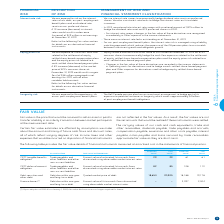According to Bce's financial document, What is fair value? the price that would be received to sell an asset or paid to transfer a liability in an orderly transaction between market participants at the measurement date.. The document states: "Fair value is the price that would be received to sell an asset or paid to transfer a liability in an orderly transaction between market participants ..." Also, What is the fair value methodology for debt securities and other debt? Quoted market price of debt. The document states: "debt Debt due within one year and long-term debt Quoted market price of debt 18,653 20,905 18,188 19,178..." Also, Which segments approximate fair value as they are short-term? The carrying values of our cash and cash equivalents, trade and other receivables, dividends payable, trade payables and accruals, compensation payable, severance and other costs payable, interest payable, notes payable and loans secured by trade receivables. The document states: "The carrying values of our cash and cash equivalents, trade and other receivables, dividends payable, trade payables and accruals, compensation payabl..." Also, can you calculate: What is the percentage change in carrying values for CRTC deferral account obligation in 2019? To answer this question, I need to perform calculations using the financial data. The calculation is: (82-108)/108, which equals -24.07 (percentage). This is based on the information: "nted using observable market interest rates 82 85 108 112 discounted using observable market interest rates 82 85 108 112..." The key data points involved are: 108, 82. Also, can you calculate: What is the percentage change in fair values for CRTC tangible benefits obligation in 2019? To answer this question, I need to perform calculations using the financial data. The calculation is: (29-61)/61, which equals -52.46 (percentage). This is based on the information: "discounted using observable market interest rates 29 29 61 61 nted using observable market interest rates 29 29 61 61..." The key data points involved are: 29, 61. Also, can you calculate: What is the sum of carrying values in 2019? Based on the calculation: 29+82+18,653, the result is 18764. This is based on the information: "discounted using observable market interest rates 29 29 61 61 discounted using observable market interest rates 82 85 108 112 ar and long-term debt Quoted market price of debt 18,653 20,905 18,188 19,..." The key data points involved are: 18,653, 29, 82. 